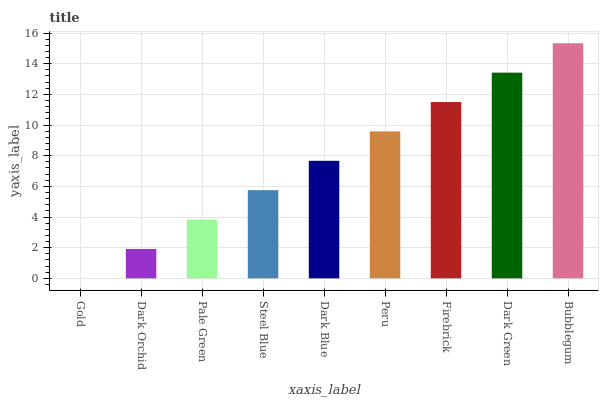Is Dark Orchid the minimum?
Answer yes or no. No. Is Dark Orchid the maximum?
Answer yes or no. No. Is Dark Orchid greater than Gold?
Answer yes or no. Yes. Is Gold less than Dark Orchid?
Answer yes or no. Yes. Is Gold greater than Dark Orchid?
Answer yes or no. No. Is Dark Orchid less than Gold?
Answer yes or no. No. Is Dark Blue the high median?
Answer yes or no. Yes. Is Dark Blue the low median?
Answer yes or no. Yes. Is Gold the high median?
Answer yes or no. No. Is Dark Green the low median?
Answer yes or no. No. 